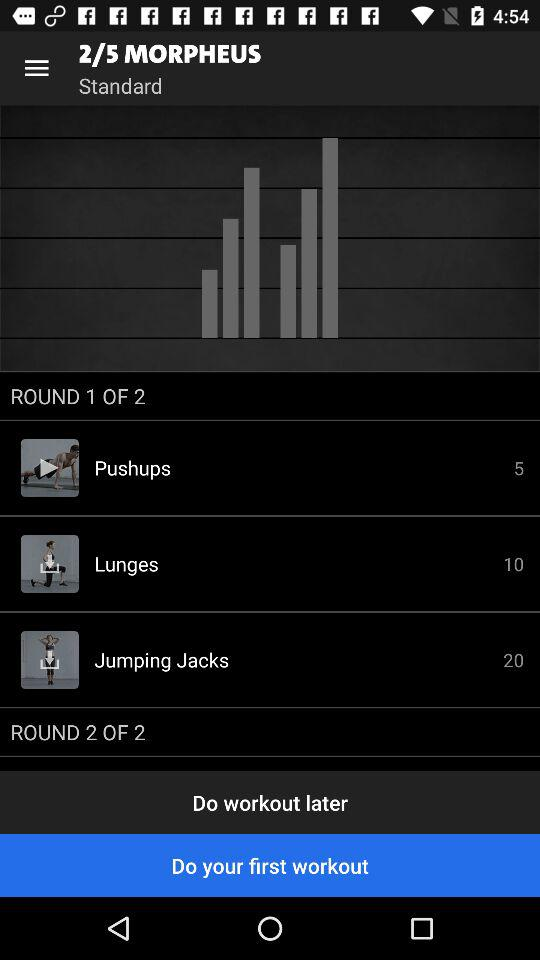How many exercises are in round 1?
Answer the question using a single word or phrase. 3 